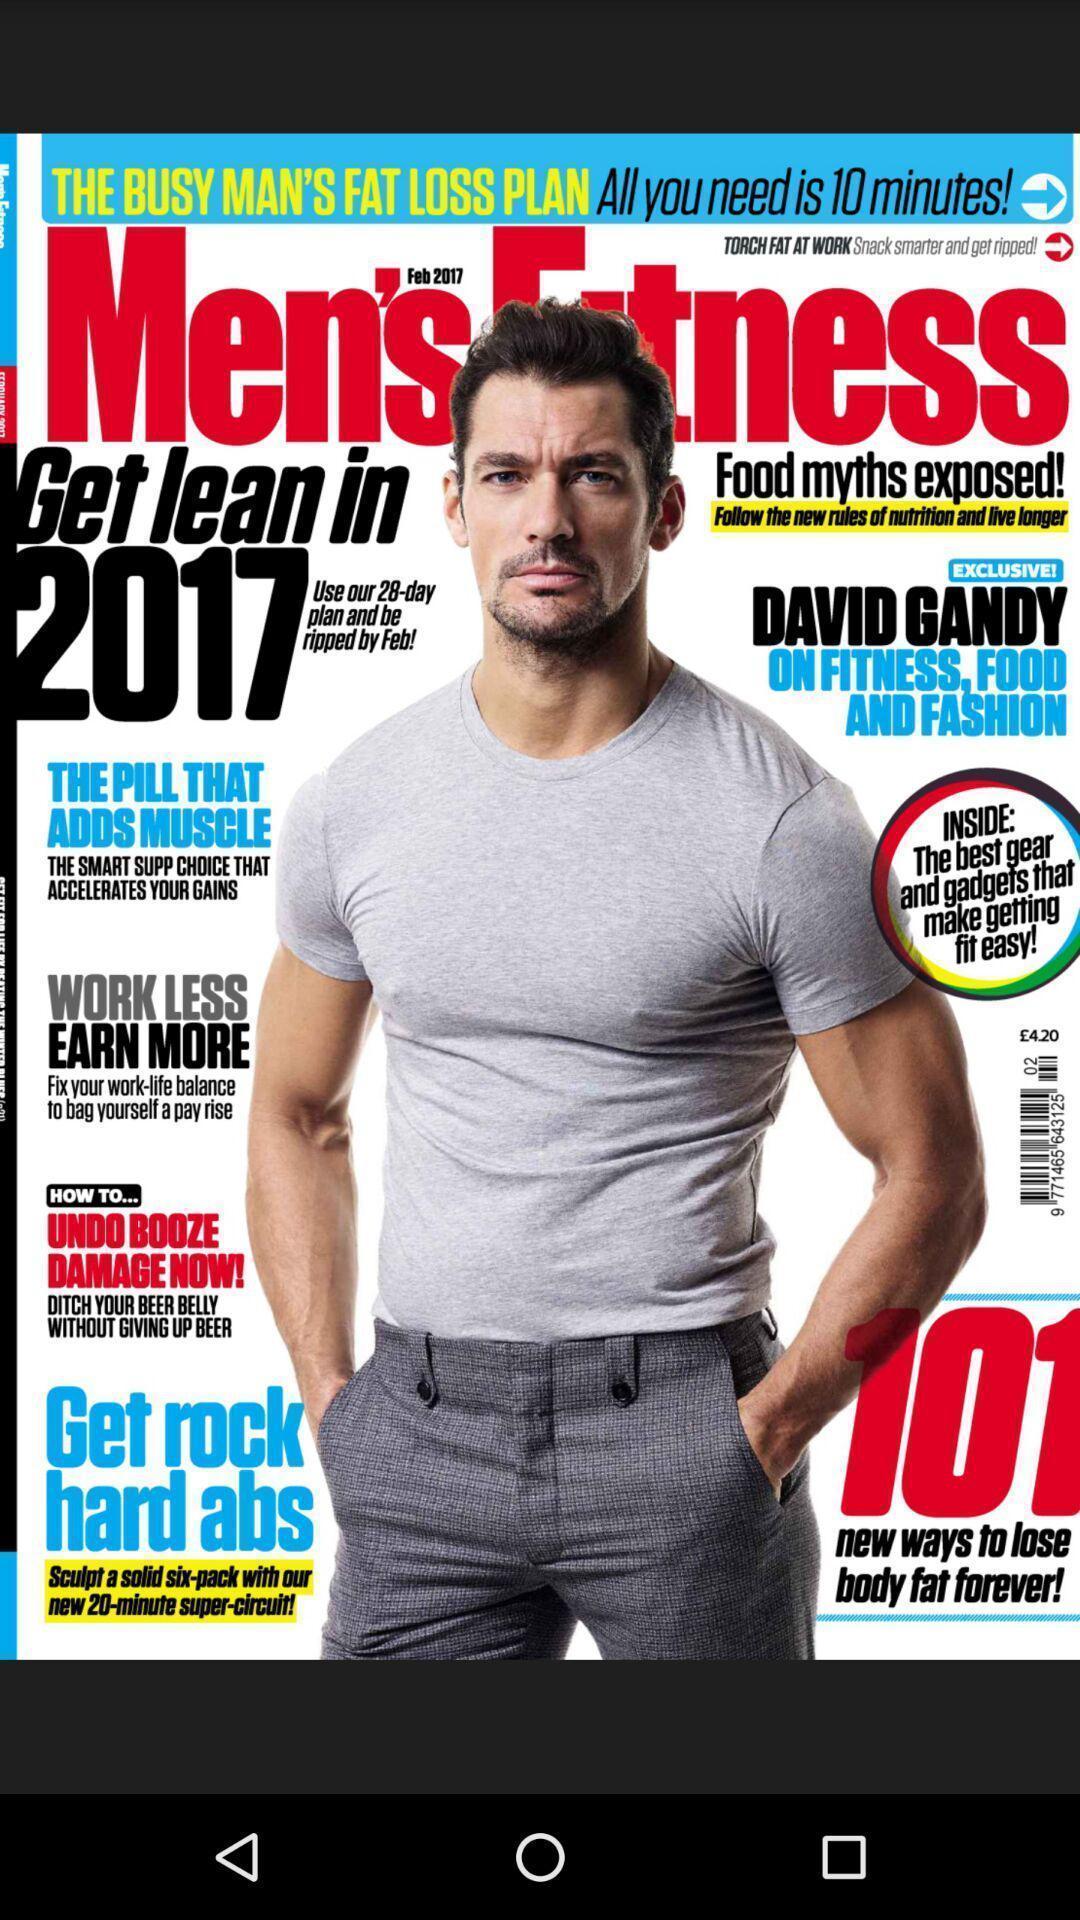What is the overall content of this screenshot? Page displaying with a image poster. 